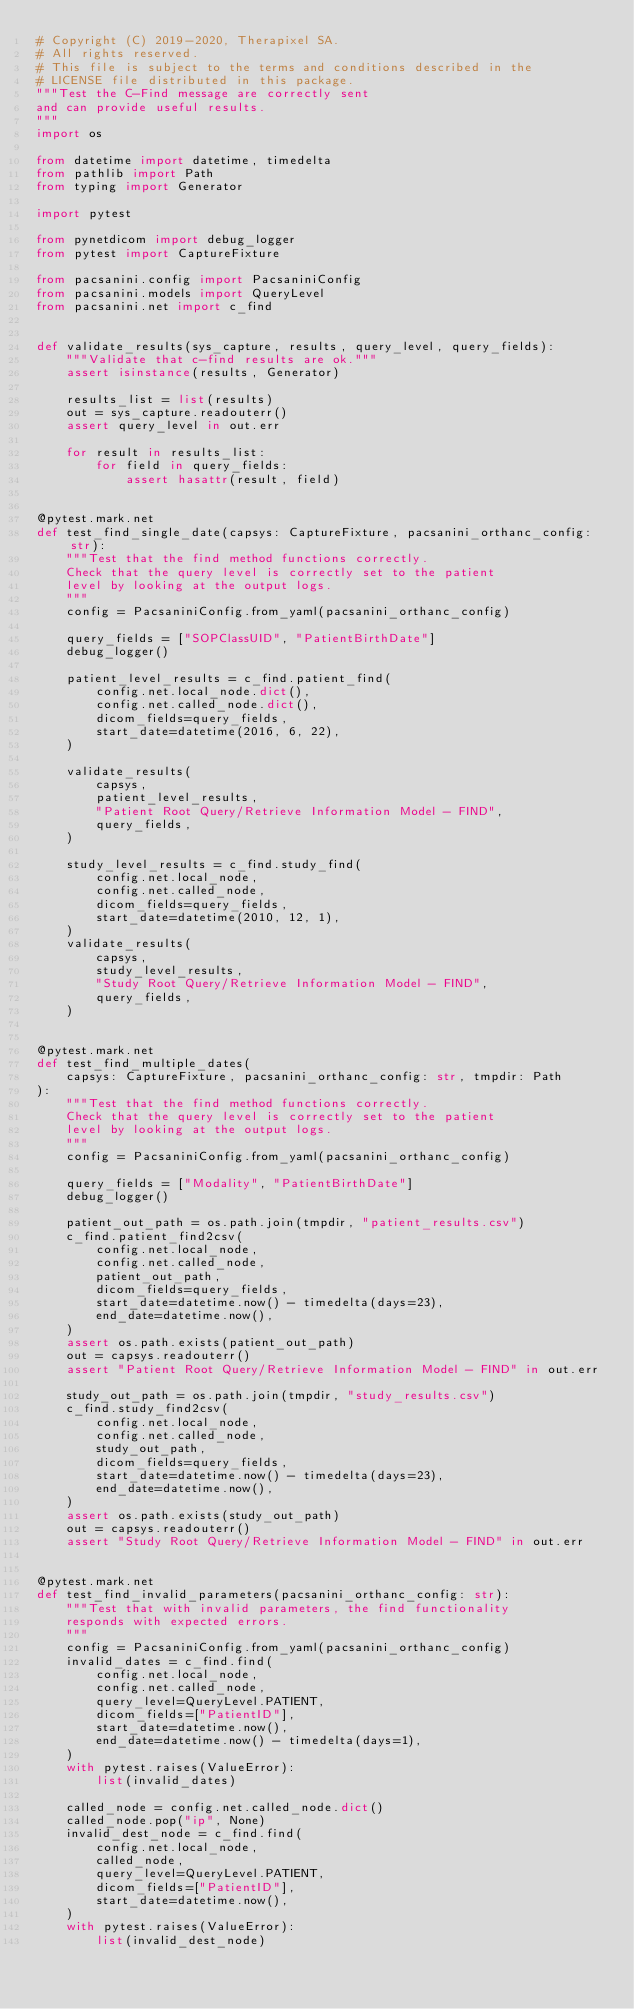<code> <loc_0><loc_0><loc_500><loc_500><_Python_># Copyright (C) 2019-2020, Therapixel SA.
# All rights reserved.
# This file is subject to the terms and conditions described in the
# LICENSE file distributed in this package.
"""Test the C-Find message are correctly sent
and can provide useful results.
"""
import os

from datetime import datetime, timedelta
from pathlib import Path
from typing import Generator

import pytest

from pynetdicom import debug_logger
from pytest import CaptureFixture

from pacsanini.config import PacsaniniConfig
from pacsanini.models import QueryLevel
from pacsanini.net import c_find


def validate_results(sys_capture, results, query_level, query_fields):
    """Validate that c-find results are ok."""
    assert isinstance(results, Generator)

    results_list = list(results)
    out = sys_capture.readouterr()
    assert query_level in out.err

    for result in results_list:
        for field in query_fields:
            assert hasattr(result, field)


@pytest.mark.net
def test_find_single_date(capsys: CaptureFixture, pacsanini_orthanc_config: str):
    """Test that the find method functions correctly.
    Check that the query level is correctly set to the patient
    level by looking at the output logs.
    """
    config = PacsaniniConfig.from_yaml(pacsanini_orthanc_config)

    query_fields = ["SOPClassUID", "PatientBirthDate"]
    debug_logger()

    patient_level_results = c_find.patient_find(
        config.net.local_node.dict(),
        config.net.called_node.dict(),
        dicom_fields=query_fields,
        start_date=datetime(2016, 6, 22),
    )

    validate_results(
        capsys,
        patient_level_results,
        "Patient Root Query/Retrieve Information Model - FIND",
        query_fields,
    )

    study_level_results = c_find.study_find(
        config.net.local_node,
        config.net.called_node,
        dicom_fields=query_fields,
        start_date=datetime(2010, 12, 1),
    )
    validate_results(
        capsys,
        study_level_results,
        "Study Root Query/Retrieve Information Model - FIND",
        query_fields,
    )


@pytest.mark.net
def test_find_multiple_dates(
    capsys: CaptureFixture, pacsanini_orthanc_config: str, tmpdir: Path
):
    """Test that the find method functions correctly.
    Check that the query level is correctly set to the patient
    level by looking at the output logs.
    """
    config = PacsaniniConfig.from_yaml(pacsanini_orthanc_config)

    query_fields = ["Modality", "PatientBirthDate"]
    debug_logger()

    patient_out_path = os.path.join(tmpdir, "patient_results.csv")
    c_find.patient_find2csv(
        config.net.local_node,
        config.net.called_node,
        patient_out_path,
        dicom_fields=query_fields,
        start_date=datetime.now() - timedelta(days=23),
        end_date=datetime.now(),
    )
    assert os.path.exists(patient_out_path)
    out = capsys.readouterr()
    assert "Patient Root Query/Retrieve Information Model - FIND" in out.err

    study_out_path = os.path.join(tmpdir, "study_results.csv")
    c_find.study_find2csv(
        config.net.local_node,
        config.net.called_node,
        study_out_path,
        dicom_fields=query_fields,
        start_date=datetime.now() - timedelta(days=23),
        end_date=datetime.now(),
    )
    assert os.path.exists(study_out_path)
    out = capsys.readouterr()
    assert "Study Root Query/Retrieve Information Model - FIND" in out.err


@pytest.mark.net
def test_find_invalid_parameters(pacsanini_orthanc_config: str):
    """Test that with invalid parameters, the find functionality
    responds with expected errors.
    """
    config = PacsaniniConfig.from_yaml(pacsanini_orthanc_config)
    invalid_dates = c_find.find(
        config.net.local_node,
        config.net.called_node,
        query_level=QueryLevel.PATIENT,
        dicom_fields=["PatientID"],
        start_date=datetime.now(),
        end_date=datetime.now() - timedelta(days=1),
    )
    with pytest.raises(ValueError):
        list(invalid_dates)

    called_node = config.net.called_node.dict()
    called_node.pop("ip", None)
    invalid_dest_node = c_find.find(
        config.net.local_node,
        called_node,
        query_level=QueryLevel.PATIENT,
        dicom_fields=["PatientID"],
        start_date=datetime.now(),
    )
    with pytest.raises(ValueError):
        list(invalid_dest_node)
</code> 